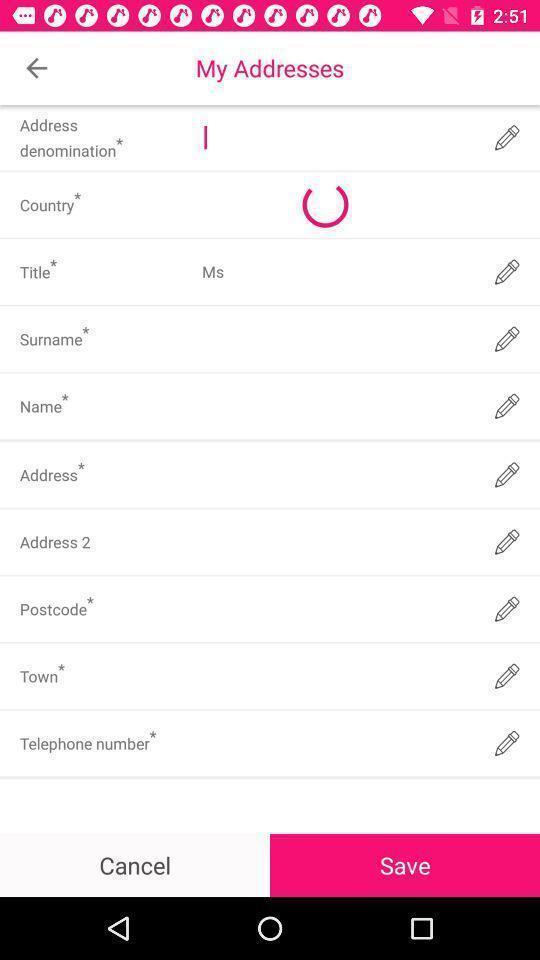Tell me what you see in this picture. Screen showing fields to enter. 